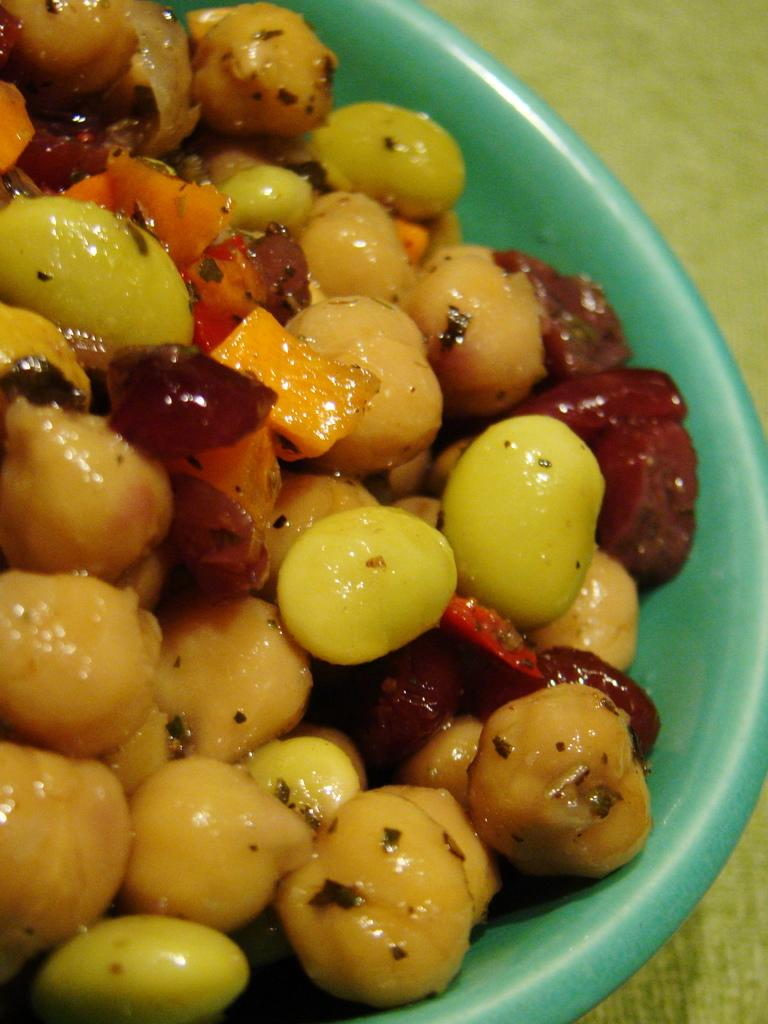What color is the bowl in the image? The bowl in the image is green. What is inside the bowl? The bowl contains food items. On what surface is the bowl placed? The bowl is placed on a wooden surface. Can you tell me how many people are talking near the border in the image? There is no mention of people talking or a border in the image; it only features a green color bowl containing food items and placed on a wooden surface. 